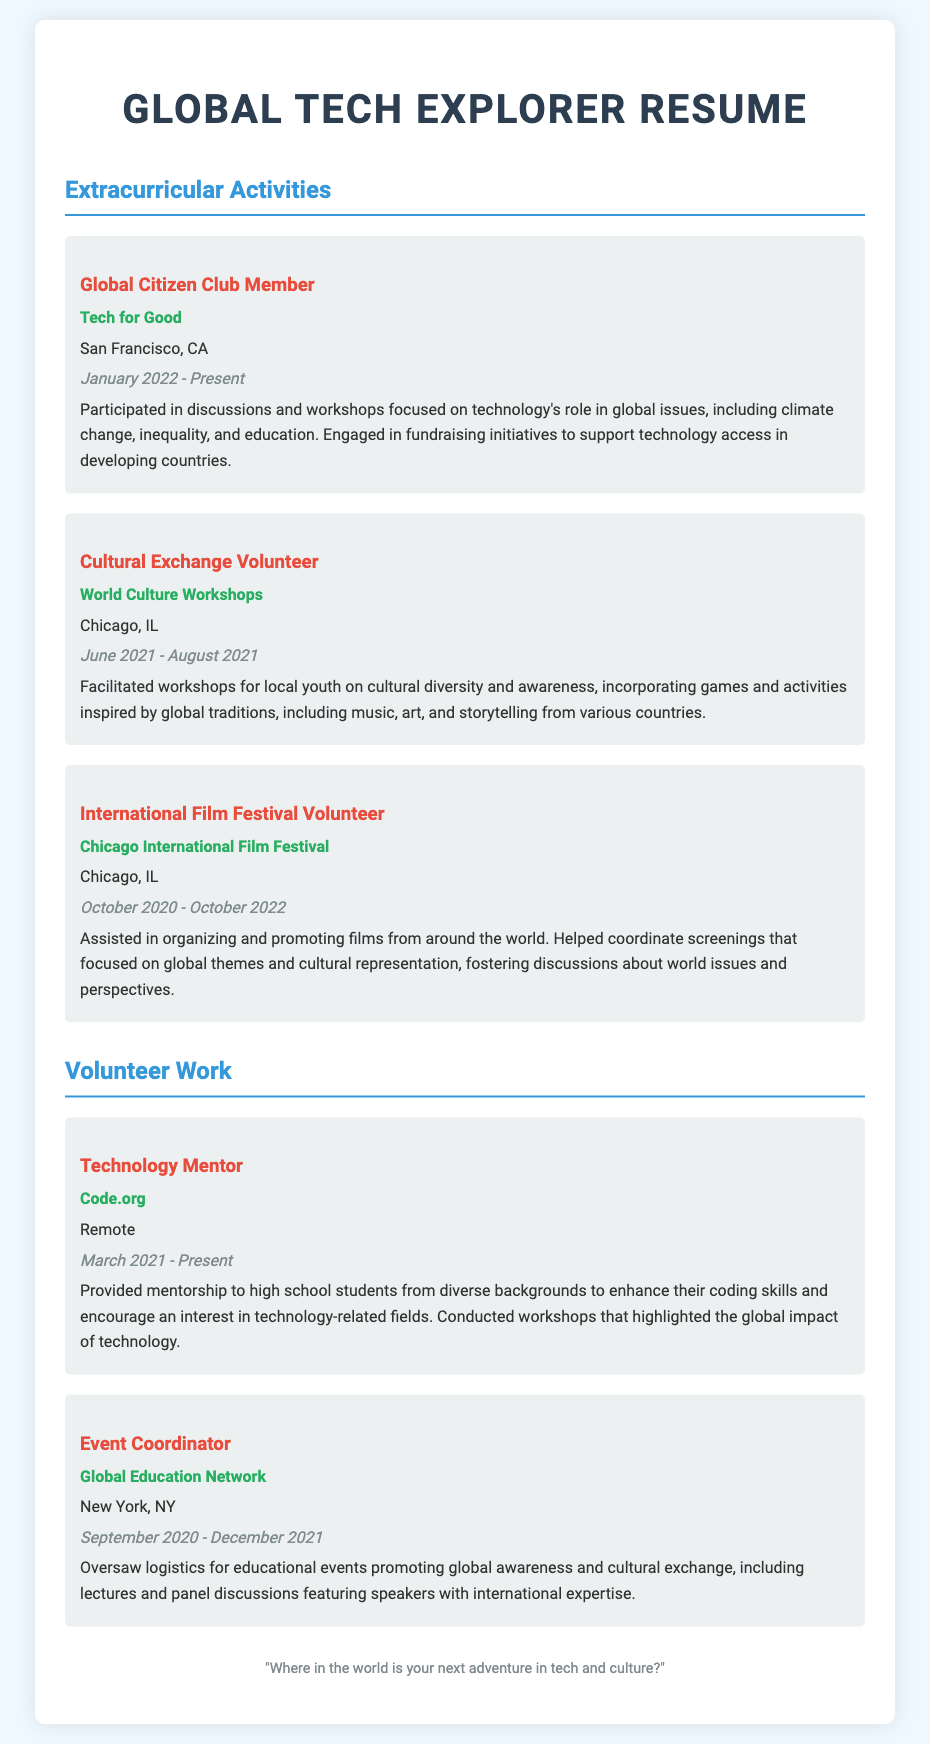What is the name of the organization for the Global Citizen Club Member? The organization mentioned for the Global Citizen Club Member is Tech for Good.
Answer: Tech for Good When did the Cultural Exchange Volunteer role take place? The dates for the Cultural Exchange Volunteer role are June 2021 to August 2021.
Answer: June 2021 - August 2021 How long did the International Film Festival Volunteer serve? The duration of the International Film Festival Volunteer service is from October 2020 to October 2022, which is 2 years.
Answer: 2 years What is the title of the volunteer role associated with Code.org? The title of the volunteer role associated with Code.org is Technology Mentor.
Answer: Technology Mentor What city is the Global Education Network based in? The location of the Global Education Network is New York, NY.
Answer: New York, NY What type of events did the Event Coordinator oversee? The Event Coordinator oversaw educational events promoting global awareness and cultural exchange.
Answer: Educational events How many extracurricular activities are listed in the document? The document lists three extracurricular activities.
Answer: Three What type of workshops facilitated by the Cultural Exchange Volunteer? The Cultural Exchange Volunteer facilitated workshops on cultural diversity and awareness.
Answer: Cultural diversity and awareness What mission statement is included in the footer? The footer includes the mission statement about adventures in tech and culture.
Answer: "Where in the world is your next adventure in tech and culture?" 